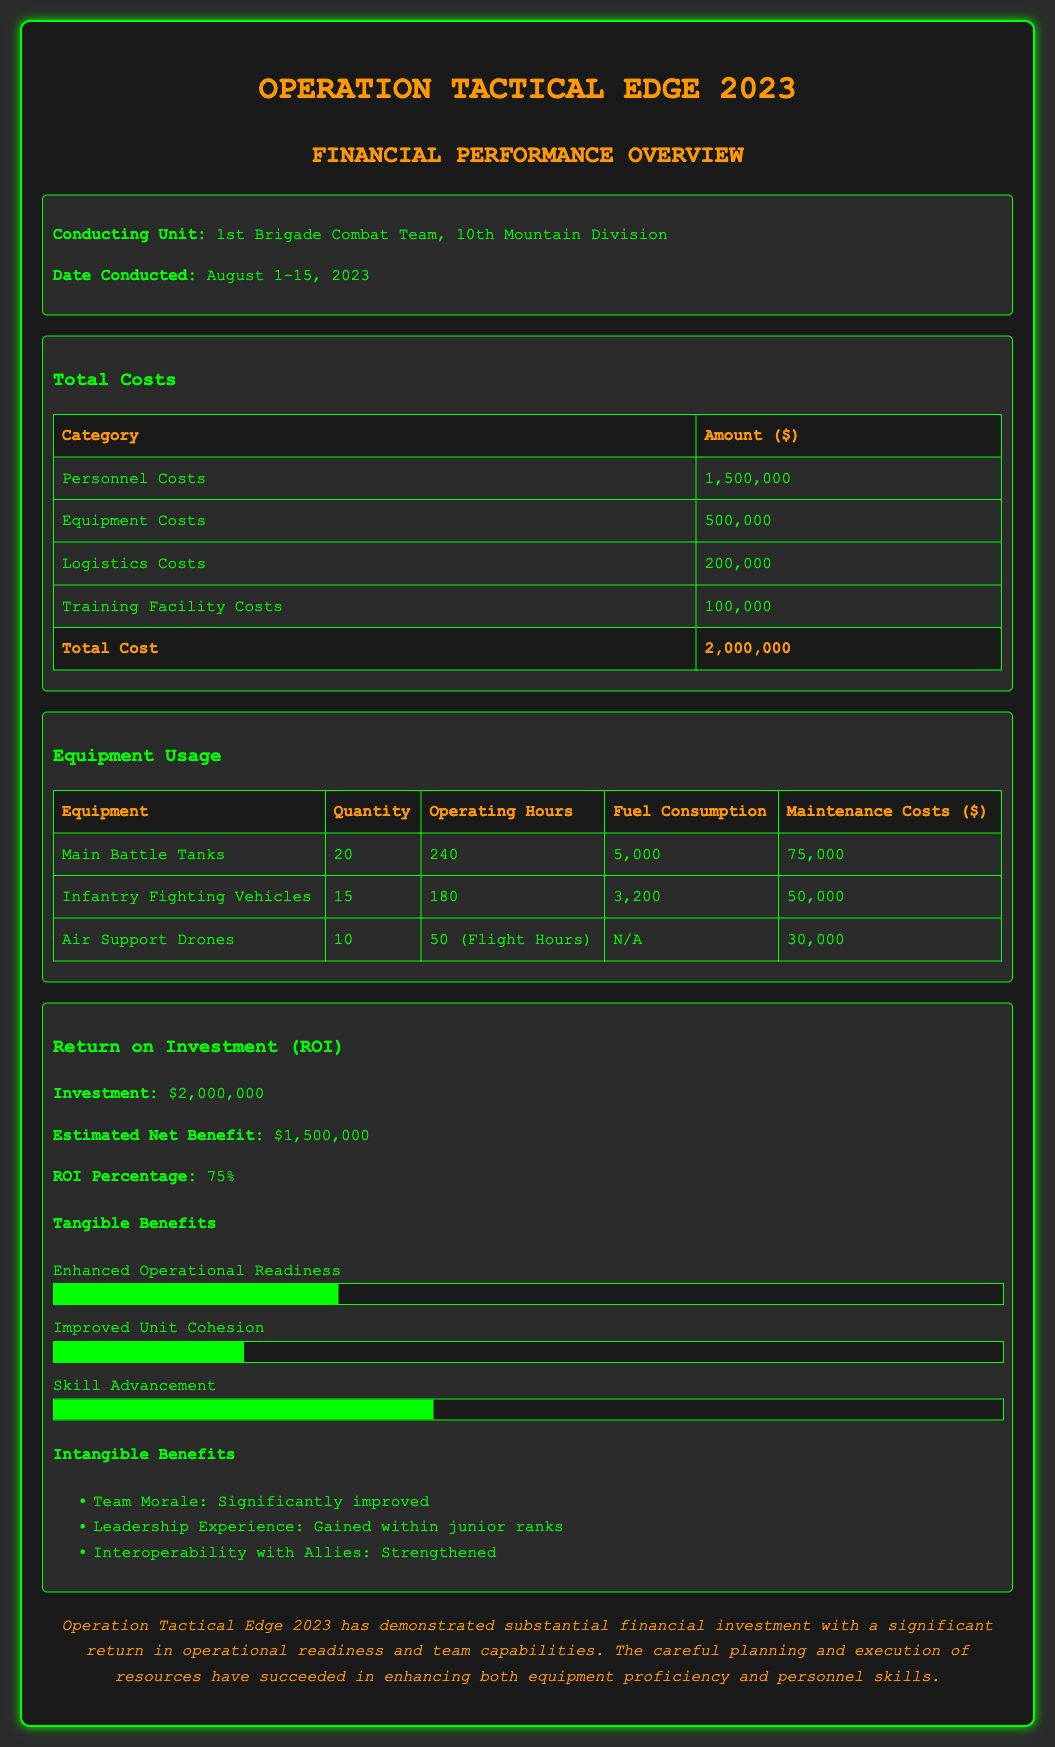What were the total personnel costs? The document lists personnel costs under the total costs section, which amounts to $1,500,000.
Answer: $1,500,000 How many Main Battle Tanks were utilized? The equipment usage table shows that 20 Main Battle Tanks were utilized during the exercise.
Answer: 20 What is the total cost of the operation? The total cost is the sum of all categories listed in the total costs section, which is $2,000,000.
Answer: $2,000,000 What was the Return on Investment (ROI) percentage? The ROI percentage is stated clearly in the Return on Investment section, which is 75%.
Answer: 75% How many operating hours were recorded for Infantry Fighting Vehicles? The equipment usage table indicates that Infantry Fighting Vehicles operated for 180 hours.
Answer: 180 What was the estimated net benefit of the operation? The estimated net benefit is provided in the ROI section, which is $1,500,000.
Answer: $1,500,000 What percentage of tangible benefits is reflected in Skill Advancement? The progress bar indicates that Skill Advancement represents 40% of tangible benefits from the operation.
Answer: 40% What was the total fuel consumption reported for Main Battle Tanks? The document specifies the total fuel consumption for Main Battle Tanks as 5,000.
Answer: 5,000 What intangible benefit is highlighted regarding team morale? The document notes that team morale has significantly improved as an intangible benefit.
Answer: Significantly improved 